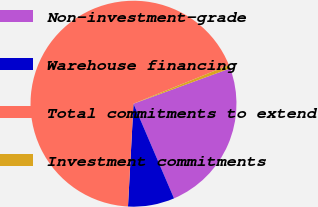Convert chart to OTSL. <chart><loc_0><loc_0><loc_500><loc_500><pie_chart><fcel>Non-investment-grade<fcel>Warehouse financing<fcel>Total commitments to extend<fcel>Investment commitments<nl><fcel>24.14%<fcel>7.29%<fcel>68.02%<fcel>0.55%<nl></chart> 